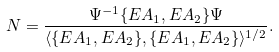<formula> <loc_0><loc_0><loc_500><loc_500>N = \frac { \Psi ^ { - 1 } \{ E A _ { 1 } , E A _ { 2 } \} \Psi } { \langle \{ E A _ { 1 } , E A _ { 2 } \} , \{ E A _ { 1 } , E A _ { 2 } \} \rangle ^ { 1 / 2 } } .</formula> 